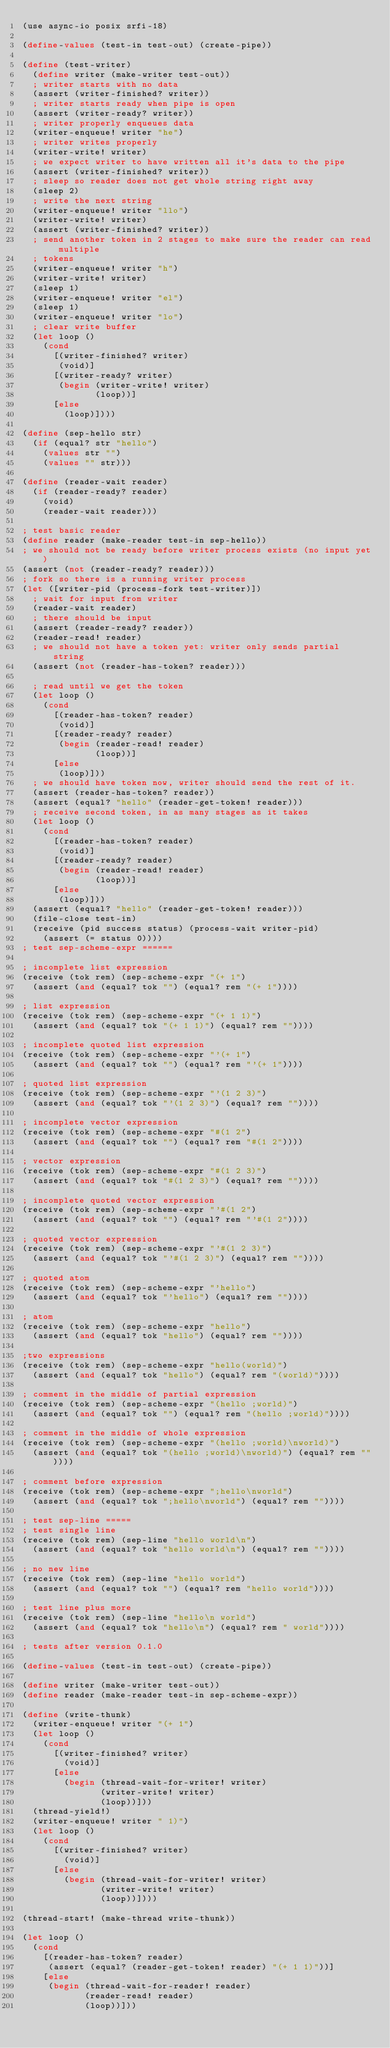<code> <loc_0><loc_0><loc_500><loc_500><_Scheme_>(use async-io posix srfi-18)

(define-values (test-in test-out) (create-pipe))

(define (test-writer)
  (define writer (make-writer test-out))
  ; writer starts with no data
  (assert (writer-finished? writer))
  ; writer starts ready when pipe is open
  (assert (writer-ready? writer))
  ; writer properly enqueues data
  (writer-enqueue! writer "he")
  ; writer writes properly
  (writer-write! writer)
  ; we expect writer to have written all it's data to the pipe
  (assert (writer-finished? writer))
  ; sleep so reader does not get whole string right away
  (sleep 2)
  ; write the next string
  (writer-enqueue! writer "llo")
  (writer-write! writer)
  (assert (writer-finished? writer))
  ; send another token in 2 stages to make sure the reader can read multiple
  ; tokens
  (writer-enqueue! writer "h")
  (writer-write! writer)
  (sleep 1)
  (writer-enqueue! writer "el")
  (sleep 1)
  (writer-enqueue! writer "lo")
  ; clear write buffer
  (let loop ()
    (cond
      [(writer-finished? writer)
       (void)]
      [(writer-ready? writer)
       (begin (writer-write! writer)
              (loop))]
      [else
        (loop)])))

(define (sep-hello str)
  (if (equal? str "hello")
    (values str "")
    (values "" str)))

(define (reader-wait reader)
  (if (reader-ready? reader)
    (void)
    (reader-wait reader)))

; test basic reader
(define reader (make-reader test-in sep-hello))
; we should not be ready before writer process exists (no input yet)
(assert (not (reader-ready? reader)))
; fork so there is a running writer process
(let ([writer-pid (process-fork test-writer)])
  ; wait for input from writer
  (reader-wait reader)
  ; there should be input
  (assert (reader-ready? reader))
  (reader-read! reader)
  ; we should not have a token yet: writer only sends partial string
  (assert (not (reader-has-token? reader)))

  ; read until we get the token
  (let loop ()
    (cond
      [(reader-has-token? reader)
       (void)]
      [(reader-ready? reader)
       (begin (reader-read! reader)
              (loop))]
      [else
       (loop)]))
  ; we should have token now, writer should send the rest of it.
  (assert (reader-has-token? reader))
  (assert (equal? "hello" (reader-get-token! reader)))
  ; receive second token, in as many stages as it takes
  (let loop ()
    (cond
      [(reader-has-token? reader)
       (void)]
      [(reader-ready? reader)
       (begin (reader-read! reader)
              (loop))]
      [else
       (loop)]))
  (assert (equal? "hello" (reader-get-token! reader)))
  (file-close test-in)
  (receive (pid success status) (process-wait writer-pid)
    (assert (= status 0))))
; test sep-scheme-expr ======

; incomplete list expression
(receive (tok rem) (sep-scheme-expr "(+ 1")
  (assert (and (equal? tok "") (equal? rem "(+ 1"))))

; list expression
(receive (tok rem) (sep-scheme-expr "(+ 1 1)")
  (assert (and (equal? tok "(+ 1 1)") (equal? rem ""))))

; incomplete quoted list expression
(receive (tok rem) (sep-scheme-expr "'(+ 1")
  (assert (and (equal? tok "") (equal? rem "'(+ 1"))))

; quoted list expression
(receive (tok rem) (sep-scheme-expr "'(1 2 3)")
  (assert (and (equal? tok "'(1 2 3)") (equal? rem ""))))

; incomplete vector expression
(receive (tok rem) (sep-scheme-expr "#(1 2")
  (assert (and (equal? tok "") (equal? rem "#(1 2"))))

; vector expression
(receive (tok rem) (sep-scheme-expr "#(1 2 3)")
  (assert (and (equal? tok "#(1 2 3)") (equal? rem ""))))

; incomplete quoted vector expression
(receive (tok rem) (sep-scheme-expr "'#(1 2")
  (assert (and (equal? tok "") (equal? rem "'#(1 2"))))

; quoted vector expression
(receive (tok rem) (sep-scheme-expr "'#(1 2 3)")
  (assert (and (equal? tok "'#(1 2 3)") (equal? rem ""))))

; quoted atom
(receive (tok rem) (sep-scheme-expr "'hello")
  (assert (and (equal? tok "'hello") (equal? rem ""))))

; atom
(receive (tok rem) (sep-scheme-expr "hello")
  (assert (and (equal? tok "hello") (equal? rem ""))))

;two expressions
(receive (tok rem) (sep-scheme-expr "hello(world)")
  (assert (and (equal? tok "hello") (equal? rem "(world)"))))

; comment in the middle of partial expression
(receive (tok rem) (sep-scheme-expr "(hello ;world)")
  (assert (and (equal? tok "") (equal? rem "(hello ;world)"))))

; comment in the middle of whole expression
(receive (tok rem) (sep-scheme-expr "(hello ;world)\nworld)")
  (assert (and (equal? tok "(hello ;world)\nworld)") (equal? rem ""))))

; comment before expression
(receive (tok rem) (sep-scheme-expr ";hello\nworld")
  (assert (and (equal? tok ";hello\nworld") (equal? rem ""))))

; test sep-line =====
; test single line
(receive (tok rem) (sep-line "hello world\n")
  (assert (and (equal? tok "hello world\n") (equal? rem ""))))

; no new line
(receive (tok rem) (sep-line "hello world")
  (assert (and (equal? tok "") (equal? rem "hello world"))))

; test line plus more
(receive (tok rem) (sep-line "hello\n world")
  (assert (and (equal? tok "hello\n") (equal? rem " world"))))

; tests after version 0.1.0

(define-values (test-in test-out) (create-pipe))

(define writer (make-writer test-out))
(define reader (make-reader test-in sep-scheme-expr))

(define (write-thunk)
  (writer-enqueue! writer "(+ 1")
  (let loop ()
    (cond
      [(writer-finished? writer)
        (void)]
      [else
        (begin (thread-wait-for-writer! writer)
               (writer-write! writer)
               (loop))]))
  (thread-yield!)
  (writer-enqueue! writer " 1)")
  (let loop ()
    (cond
      [(writer-finished? writer)
        (void)]
      [else
        (begin (thread-wait-for-writer! writer)
               (writer-write! writer)
               (loop))])))

(thread-start! (make-thread write-thunk))

(let loop ()
  (cond
    [(reader-has-token? reader)
     (assert (equal? (reader-get-token! reader) "(+ 1 1)"))]
    [else
     (begin (thread-wait-for-reader! reader)
            (reader-read! reader)
            (loop))]))

</code> 